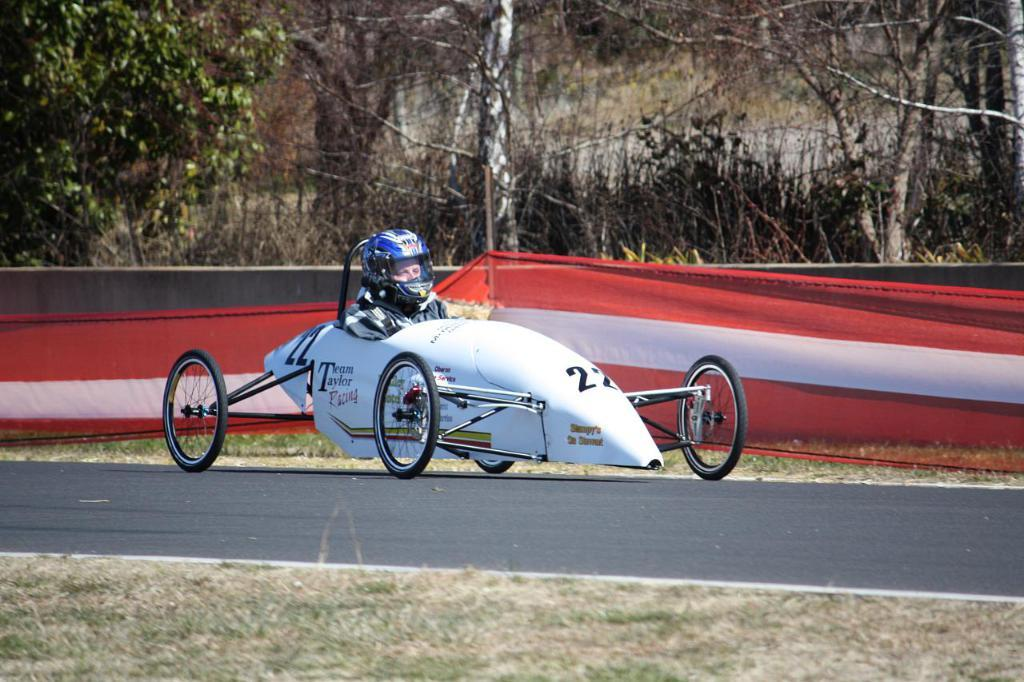What is the main subject of the image? The main subject of the image is a car. Who or what is inside the car? A human is seated in the car. What is the person wearing? The person is wearing a helmet. What else can be seen in the image besides the car and the person? There is a cloth and trees visible in the image. What type of grass is growing on the person's face in the image? There is no grass growing on the person's face in the image. 